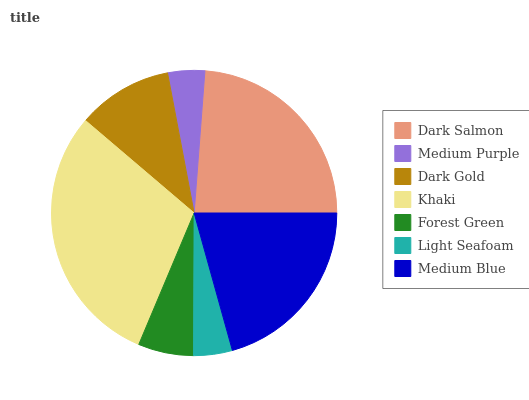Is Medium Purple the minimum?
Answer yes or no. Yes. Is Khaki the maximum?
Answer yes or no. Yes. Is Dark Gold the minimum?
Answer yes or no. No. Is Dark Gold the maximum?
Answer yes or no. No. Is Dark Gold greater than Medium Purple?
Answer yes or no. Yes. Is Medium Purple less than Dark Gold?
Answer yes or no. Yes. Is Medium Purple greater than Dark Gold?
Answer yes or no. No. Is Dark Gold less than Medium Purple?
Answer yes or no. No. Is Dark Gold the high median?
Answer yes or no. Yes. Is Dark Gold the low median?
Answer yes or no. Yes. Is Dark Salmon the high median?
Answer yes or no. No. Is Medium Blue the low median?
Answer yes or no. No. 